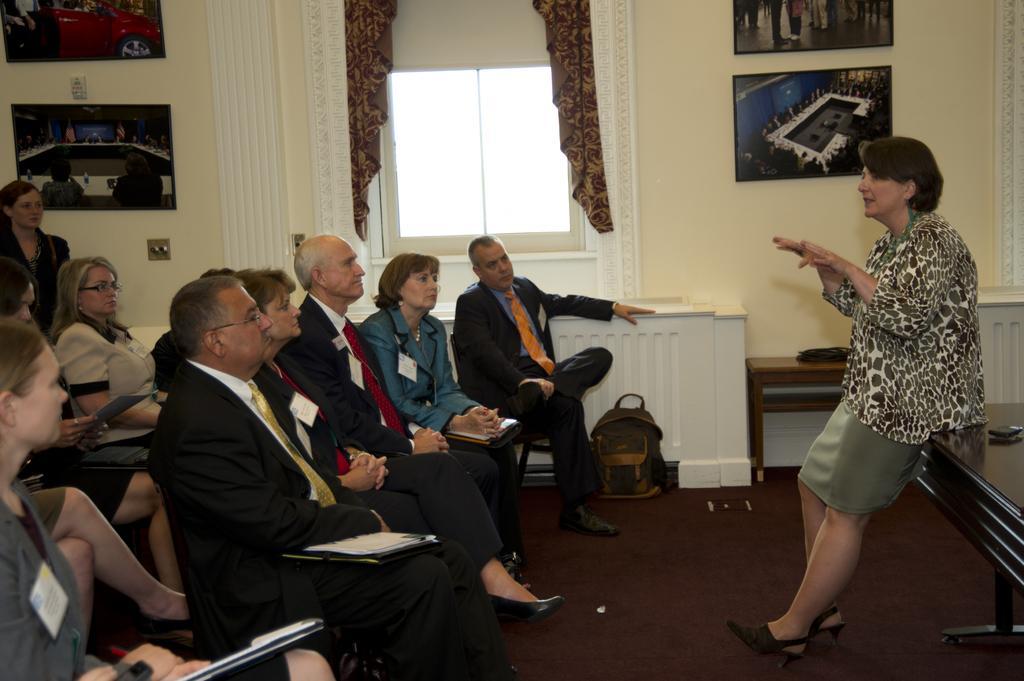How would you summarize this image in a sentence or two? On the right side of the image there is a lady standing, behind her there is a table. On the left side there are some people sitting on the chairs and holding some objects in their hands. In the background there are some posters and a window are attached to the wall. 